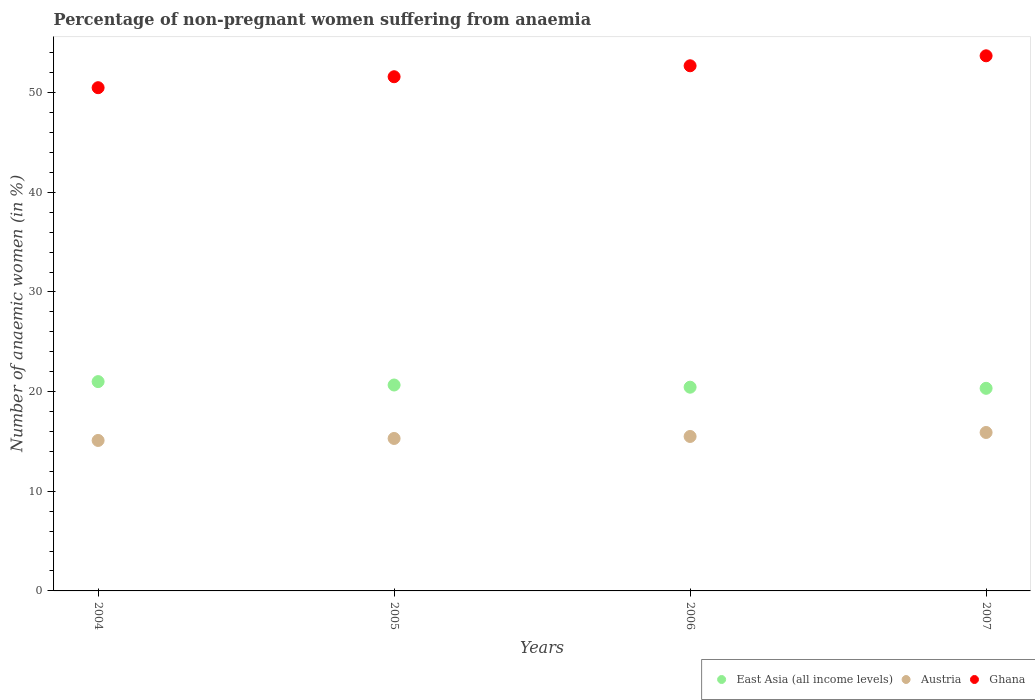Across all years, what is the maximum percentage of non-pregnant women suffering from anaemia in Austria?
Provide a succinct answer. 15.9. What is the total percentage of non-pregnant women suffering from anaemia in East Asia (all income levels) in the graph?
Give a very brief answer. 82.44. What is the difference between the percentage of non-pregnant women suffering from anaemia in Ghana in 2004 and that in 2006?
Your response must be concise. -2.2. What is the difference between the percentage of non-pregnant women suffering from anaemia in Ghana in 2004 and the percentage of non-pregnant women suffering from anaemia in East Asia (all income levels) in 2007?
Your answer should be compact. 30.17. What is the average percentage of non-pregnant women suffering from anaemia in Austria per year?
Your answer should be compact. 15.45. In the year 2005, what is the difference between the percentage of non-pregnant women suffering from anaemia in Austria and percentage of non-pregnant women suffering from anaemia in Ghana?
Provide a succinct answer. -36.3. What is the ratio of the percentage of non-pregnant women suffering from anaemia in East Asia (all income levels) in 2005 to that in 2007?
Make the answer very short. 1.02. Is the percentage of non-pregnant women suffering from anaemia in Ghana in 2004 less than that in 2006?
Make the answer very short. Yes. What is the difference between the highest and the second highest percentage of non-pregnant women suffering from anaemia in Austria?
Provide a short and direct response. 0.4. What is the difference between the highest and the lowest percentage of non-pregnant women suffering from anaemia in East Asia (all income levels)?
Provide a succinct answer. 0.67. Is it the case that in every year, the sum of the percentage of non-pregnant women suffering from anaemia in East Asia (all income levels) and percentage of non-pregnant women suffering from anaemia in Ghana  is greater than the percentage of non-pregnant women suffering from anaemia in Austria?
Keep it short and to the point. Yes. Is the percentage of non-pregnant women suffering from anaemia in Ghana strictly greater than the percentage of non-pregnant women suffering from anaemia in Austria over the years?
Ensure brevity in your answer.  Yes. Is the percentage of non-pregnant women suffering from anaemia in Austria strictly less than the percentage of non-pregnant women suffering from anaemia in Ghana over the years?
Make the answer very short. Yes. How many years are there in the graph?
Your response must be concise. 4. What is the difference between two consecutive major ticks on the Y-axis?
Your answer should be very brief. 10. Are the values on the major ticks of Y-axis written in scientific E-notation?
Offer a terse response. No. Where does the legend appear in the graph?
Ensure brevity in your answer.  Bottom right. How many legend labels are there?
Your answer should be very brief. 3. What is the title of the graph?
Provide a succinct answer. Percentage of non-pregnant women suffering from anaemia. What is the label or title of the Y-axis?
Offer a terse response. Number of anaemic women (in %). What is the Number of anaemic women (in %) in East Asia (all income levels) in 2004?
Your response must be concise. 21. What is the Number of anaemic women (in %) of Ghana in 2004?
Your answer should be very brief. 50.5. What is the Number of anaemic women (in %) in East Asia (all income levels) in 2005?
Keep it short and to the point. 20.66. What is the Number of anaemic women (in %) in Ghana in 2005?
Provide a succinct answer. 51.6. What is the Number of anaemic women (in %) in East Asia (all income levels) in 2006?
Ensure brevity in your answer.  20.44. What is the Number of anaemic women (in %) of Austria in 2006?
Your response must be concise. 15.5. What is the Number of anaemic women (in %) in Ghana in 2006?
Provide a short and direct response. 52.7. What is the Number of anaemic women (in %) in East Asia (all income levels) in 2007?
Keep it short and to the point. 20.33. What is the Number of anaemic women (in %) in Austria in 2007?
Keep it short and to the point. 15.9. What is the Number of anaemic women (in %) of Ghana in 2007?
Ensure brevity in your answer.  53.7. Across all years, what is the maximum Number of anaemic women (in %) in East Asia (all income levels)?
Ensure brevity in your answer.  21. Across all years, what is the maximum Number of anaemic women (in %) in Austria?
Give a very brief answer. 15.9. Across all years, what is the maximum Number of anaemic women (in %) of Ghana?
Offer a very short reply. 53.7. Across all years, what is the minimum Number of anaemic women (in %) in East Asia (all income levels)?
Provide a short and direct response. 20.33. Across all years, what is the minimum Number of anaemic women (in %) in Ghana?
Offer a very short reply. 50.5. What is the total Number of anaemic women (in %) of East Asia (all income levels) in the graph?
Keep it short and to the point. 82.44. What is the total Number of anaemic women (in %) in Austria in the graph?
Your answer should be very brief. 61.8. What is the total Number of anaemic women (in %) of Ghana in the graph?
Ensure brevity in your answer.  208.5. What is the difference between the Number of anaemic women (in %) in East Asia (all income levels) in 2004 and that in 2005?
Your answer should be very brief. 0.34. What is the difference between the Number of anaemic women (in %) in Ghana in 2004 and that in 2005?
Provide a succinct answer. -1.1. What is the difference between the Number of anaemic women (in %) in East Asia (all income levels) in 2004 and that in 2006?
Offer a very short reply. 0.56. What is the difference between the Number of anaemic women (in %) of Austria in 2004 and that in 2006?
Provide a succinct answer. -0.4. What is the difference between the Number of anaemic women (in %) of Ghana in 2004 and that in 2006?
Your response must be concise. -2.2. What is the difference between the Number of anaemic women (in %) in East Asia (all income levels) in 2004 and that in 2007?
Your answer should be very brief. 0.67. What is the difference between the Number of anaemic women (in %) in Austria in 2004 and that in 2007?
Make the answer very short. -0.8. What is the difference between the Number of anaemic women (in %) in Ghana in 2004 and that in 2007?
Offer a terse response. -3.2. What is the difference between the Number of anaemic women (in %) in East Asia (all income levels) in 2005 and that in 2006?
Keep it short and to the point. 0.22. What is the difference between the Number of anaemic women (in %) in Austria in 2005 and that in 2006?
Keep it short and to the point. -0.2. What is the difference between the Number of anaemic women (in %) in Ghana in 2005 and that in 2006?
Provide a succinct answer. -1.1. What is the difference between the Number of anaemic women (in %) in East Asia (all income levels) in 2005 and that in 2007?
Give a very brief answer. 0.33. What is the difference between the Number of anaemic women (in %) in Ghana in 2005 and that in 2007?
Provide a succinct answer. -2.1. What is the difference between the Number of anaemic women (in %) of East Asia (all income levels) in 2006 and that in 2007?
Make the answer very short. 0.11. What is the difference between the Number of anaemic women (in %) in East Asia (all income levels) in 2004 and the Number of anaemic women (in %) in Austria in 2005?
Provide a short and direct response. 5.7. What is the difference between the Number of anaemic women (in %) of East Asia (all income levels) in 2004 and the Number of anaemic women (in %) of Ghana in 2005?
Keep it short and to the point. -30.6. What is the difference between the Number of anaemic women (in %) in Austria in 2004 and the Number of anaemic women (in %) in Ghana in 2005?
Give a very brief answer. -36.5. What is the difference between the Number of anaemic women (in %) in East Asia (all income levels) in 2004 and the Number of anaemic women (in %) in Austria in 2006?
Make the answer very short. 5.5. What is the difference between the Number of anaemic women (in %) in East Asia (all income levels) in 2004 and the Number of anaemic women (in %) in Ghana in 2006?
Provide a succinct answer. -31.7. What is the difference between the Number of anaemic women (in %) in Austria in 2004 and the Number of anaemic women (in %) in Ghana in 2006?
Your answer should be compact. -37.6. What is the difference between the Number of anaemic women (in %) in East Asia (all income levels) in 2004 and the Number of anaemic women (in %) in Austria in 2007?
Keep it short and to the point. 5.1. What is the difference between the Number of anaemic women (in %) in East Asia (all income levels) in 2004 and the Number of anaemic women (in %) in Ghana in 2007?
Keep it short and to the point. -32.7. What is the difference between the Number of anaemic women (in %) in Austria in 2004 and the Number of anaemic women (in %) in Ghana in 2007?
Ensure brevity in your answer.  -38.6. What is the difference between the Number of anaemic women (in %) in East Asia (all income levels) in 2005 and the Number of anaemic women (in %) in Austria in 2006?
Give a very brief answer. 5.16. What is the difference between the Number of anaemic women (in %) in East Asia (all income levels) in 2005 and the Number of anaemic women (in %) in Ghana in 2006?
Provide a short and direct response. -32.04. What is the difference between the Number of anaemic women (in %) of Austria in 2005 and the Number of anaemic women (in %) of Ghana in 2006?
Keep it short and to the point. -37.4. What is the difference between the Number of anaemic women (in %) in East Asia (all income levels) in 2005 and the Number of anaemic women (in %) in Austria in 2007?
Keep it short and to the point. 4.76. What is the difference between the Number of anaemic women (in %) in East Asia (all income levels) in 2005 and the Number of anaemic women (in %) in Ghana in 2007?
Provide a succinct answer. -33.04. What is the difference between the Number of anaemic women (in %) in Austria in 2005 and the Number of anaemic women (in %) in Ghana in 2007?
Your answer should be very brief. -38.4. What is the difference between the Number of anaemic women (in %) in East Asia (all income levels) in 2006 and the Number of anaemic women (in %) in Austria in 2007?
Keep it short and to the point. 4.54. What is the difference between the Number of anaemic women (in %) in East Asia (all income levels) in 2006 and the Number of anaemic women (in %) in Ghana in 2007?
Give a very brief answer. -33.26. What is the difference between the Number of anaemic women (in %) of Austria in 2006 and the Number of anaemic women (in %) of Ghana in 2007?
Ensure brevity in your answer.  -38.2. What is the average Number of anaemic women (in %) of East Asia (all income levels) per year?
Give a very brief answer. 20.61. What is the average Number of anaemic women (in %) of Austria per year?
Your answer should be very brief. 15.45. What is the average Number of anaemic women (in %) of Ghana per year?
Provide a short and direct response. 52.12. In the year 2004, what is the difference between the Number of anaemic women (in %) in East Asia (all income levels) and Number of anaemic women (in %) in Austria?
Your answer should be very brief. 5.9. In the year 2004, what is the difference between the Number of anaemic women (in %) of East Asia (all income levels) and Number of anaemic women (in %) of Ghana?
Your answer should be compact. -29.5. In the year 2004, what is the difference between the Number of anaemic women (in %) in Austria and Number of anaemic women (in %) in Ghana?
Give a very brief answer. -35.4. In the year 2005, what is the difference between the Number of anaemic women (in %) of East Asia (all income levels) and Number of anaemic women (in %) of Austria?
Your response must be concise. 5.36. In the year 2005, what is the difference between the Number of anaemic women (in %) of East Asia (all income levels) and Number of anaemic women (in %) of Ghana?
Your response must be concise. -30.94. In the year 2005, what is the difference between the Number of anaemic women (in %) in Austria and Number of anaemic women (in %) in Ghana?
Offer a very short reply. -36.3. In the year 2006, what is the difference between the Number of anaemic women (in %) in East Asia (all income levels) and Number of anaemic women (in %) in Austria?
Your answer should be very brief. 4.94. In the year 2006, what is the difference between the Number of anaemic women (in %) of East Asia (all income levels) and Number of anaemic women (in %) of Ghana?
Offer a terse response. -32.26. In the year 2006, what is the difference between the Number of anaemic women (in %) in Austria and Number of anaemic women (in %) in Ghana?
Provide a succinct answer. -37.2. In the year 2007, what is the difference between the Number of anaemic women (in %) in East Asia (all income levels) and Number of anaemic women (in %) in Austria?
Offer a terse response. 4.43. In the year 2007, what is the difference between the Number of anaemic women (in %) of East Asia (all income levels) and Number of anaemic women (in %) of Ghana?
Your answer should be compact. -33.37. In the year 2007, what is the difference between the Number of anaemic women (in %) of Austria and Number of anaemic women (in %) of Ghana?
Your answer should be very brief. -37.8. What is the ratio of the Number of anaemic women (in %) of East Asia (all income levels) in 2004 to that in 2005?
Provide a succinct answer. 1.02. What is the ratio of the Number of anaemic women (in %) of Austria in 2004 to that in 2005?
Offer a terse response. 0.99. What is the ratio of the Number of anaemic women (in %) of Ghana in 2004 to that in 2005?
Offer a terse response. 0.98. What is the ratio of the Number of anaemic women (in %) in East Asia (all income levels) in 2004 to that in 2006?
Your response must be concise. 1.03. What is the ratio of the Number of anaemic women (in %) of Austria in 2004 to that in 2006?
Provide a short and direct response. 0.97. What is the ratio of the Number of anaemic women (in %) in Ghana in 2004 to that in 2006?
Give a very brief answer. 0.96. What is the ratio of the Number of anaemic women (in %) in East Asia (all income levels) in 2004 to that in 2007?
Make the answer very short. 1.03. What is the ratio of the Number of anaemic women (in %) of Austria in 2004 to that in 2007?
Make the answer very short. 0.95. What is the ratio of the Number of anaemic women (in %) in Ghana in 2004 to that in 2007?
Your response must be concise. 0.94. What is the ratio of the Number of anaemic women (in %) of East Asia (all income levels) in 2005 to that in 2006?
Offer a terse response. 1.01. What is the ratio of the Number of anaemic women (in %) in Austria in 2005 to that in 2006?
Your response must be concise. 0.99. What is the ratio of the Number of anaemic women (in %) of Ghana in 2005 to that in 2006?
Your answer should be very brief. 0.98. What is the ratio of the Number of anaemic women (in %) of East Asia (all income levels) in 2005 to that in 2007?
Your response must be concise. 1.02. What is the ratio of the Number of anaemic women (in %) of Austria in 2005 to that in 2007?
Your answer should be very brief. 0.96. What is the ratio of the Number of anaemic women (in %) in Ghana in 2005 to that in 2007?
Provide a succinct answer. 0.96. What is the ratio of the Number of anaemic women (in %) of Austria in 2006 to that in 2007?
Ensure brevity in your answer.  0.97. What is the ratio of the Number of anaemic women (in %) in Ghana in 2006 to that in 2007?
Give a very brief answer. 0.98. What is the difference between the highest and the second highest Number of anaemic women (in %) of East Asia (all income levels)?
Offer a very short reply. 0.34. What is the difference between the highest and the second highest Number of anaemic women (in %) of Ghana?
Provide a succinct answer. 1. What is the difference between the highest and the lowest Number of anaemic women (in %) in East Asia (all income levels)?
Offer a very short reply. 0.67. 